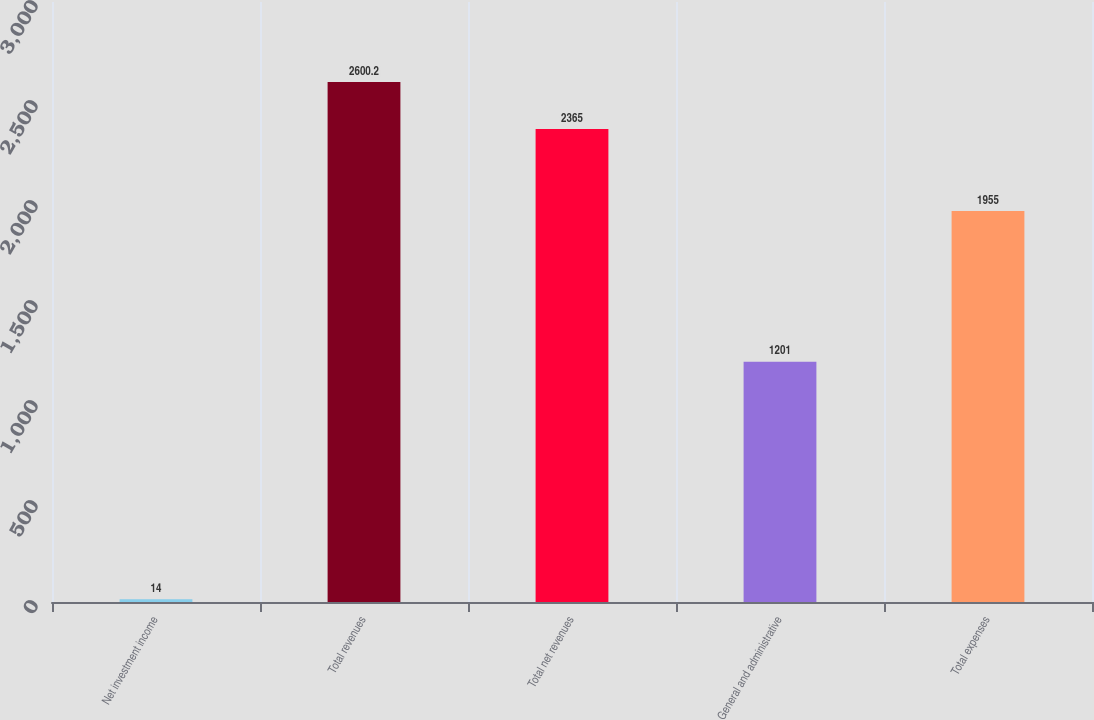Convert chart to OTSL. <chart><loc_0><loc_0><loc_500><loc_500><bar_chart><fcel>Net investment income<fcel>Total revenues<fcel>Total net revenues<fcel>General and administrative<fcel>Total expenses<nl><fcel>14<fcel>2600.2<fcel>2365<fcel>1201<fcel>1955<nl></chart> 